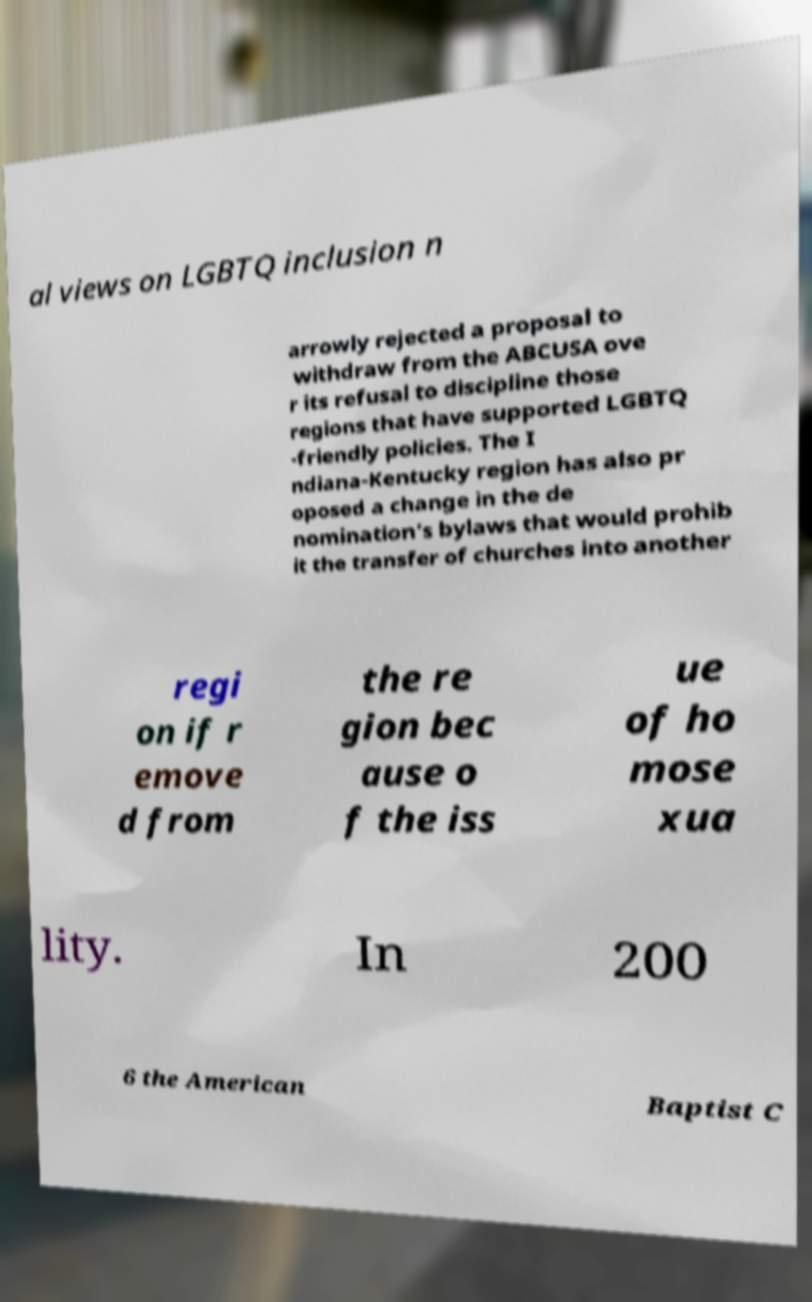Can you read and provide the text displayed in the image?This photo seems to have some interesting text. Can you extract and type it out for me? al views on LGBTQ inclusion n arrowly rejected a proposal to withdraw from the ABCUSA ove r its refusal to discipline those regions that have supported LGBTQ -friendly policies. The I ndiana-Kentucky region has also pr oposed a change in the de nomination’s bylaws that would prohib it the transfer of churches into another regi on if r emove d from the re gion bec ause o f the iss ue of ho mose xua lity. In 200 6 the American Baptist C 